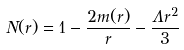<formula> <loc_0><loc_0><loc_500><loc_500>N ( r ) = 1 - \frac { 2 m ( r ) } { r } - \frac { \Lambda r ^ { 2 } } { 3 }</formula> 